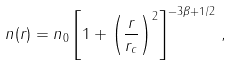<formula> <loc_0><loc_0><loc_500><loc_500>n ( r ) = n _ { 0 } \left [ 1 + \left ( \frac { r } { r _ { c } } \right ) ^ { 2 } \right ] ^ { - 3 \beta + 1 / 2 } \, ,</formula> 